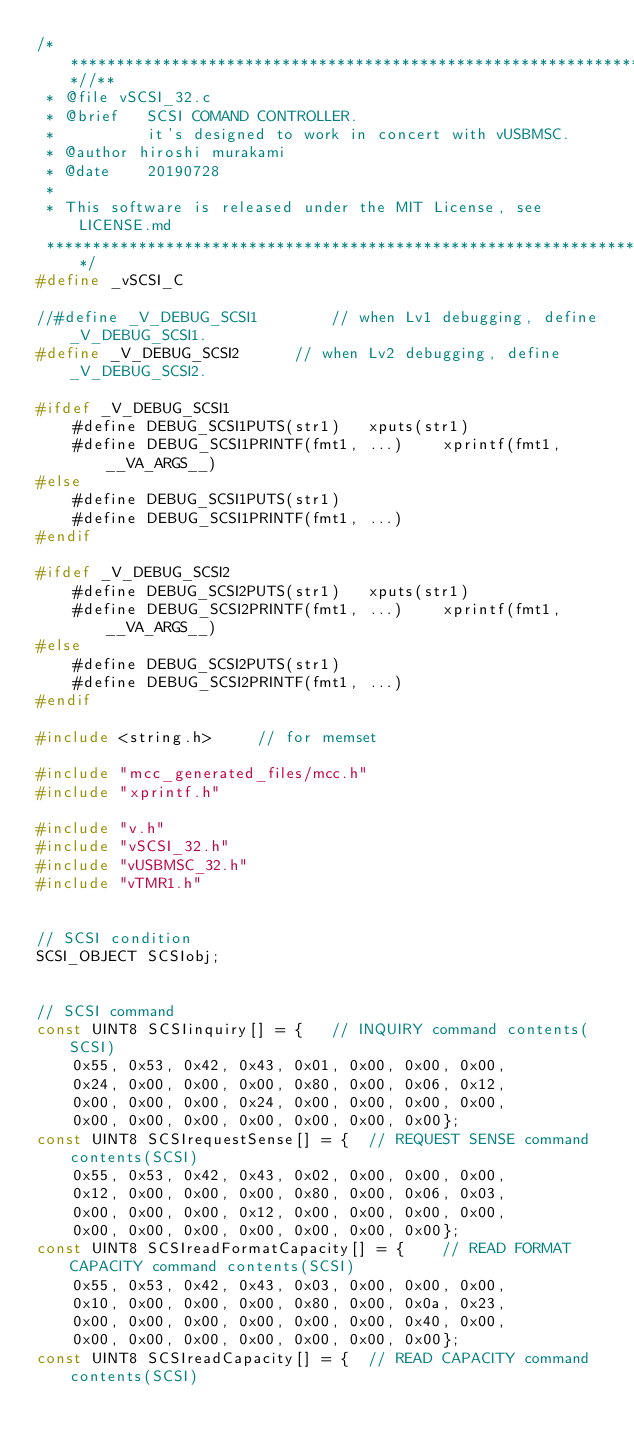Convert code to text. <code><loc_0><loc_0><loc_500><loc_500><_C_>/***************************************************************************//**
 * @file vSCSI_32.c
 * @brief	SCSI COMAND CONTROLLER.
 *			it's designed to work in concert with vUSBMSC.
 * @author hiroshi murakami
 * @date	20190728
 *
 * This software is released under the MIT License, see LICENSE.md
 ******************************************************************************/
#define _vSCSI_C

//#define _V_DEBUG_SCSI1		// when Lv1 debugging, define _V_DEBUG_SCSI1. 
#define _V_DEBUG_SCSI2		// when Lv2 debugging, define _V_DEBUG_SCSI2. 

#ifdef _V_DEBUG_SCSI1
	#define	DEBUG_SCSI1PUTS(str1)	xputs(str1)
	#define	DEBUG_SCSI1PRINTF(fmt1, ...)	xprintf(fmt1, __VA_ARGS__)
#else
	#define	DEBUG_SCSI1PUTS(str1)
	#define	DEBUG_SCSI1PRINTF(fmt1, ...)
#endif

#ifdef _V_DEBUG_SCSI2
	#define	DEBUG_SCSI2PUTS(str1)	xputs(str1)
	#define	DEBUG_SCSI2PRINTF(fmt1, ...)	xprintf(fmt1, __VA_ARGS__)
#else
	#define	DEBUG_SCSI2PUTS(str1)
	#define	DEBUG_SCSI2PRINTF(fmt1, ...)
#endif

#include <string.h>		// for memset

#include "mcc_generated_files/mcc.h"
#include "xprintf.h"

#include "v.h"
#include "vSCSI_32.h"
#include "vUSBMSC_32.h"
#include "vTMR1.h"


// SCSI condition
SCSI_OBJECT SCSIobj;


// SCSI command
const UINT8 SCSIinquiry[] = {	// INQUIRY command contents(SCSI)
	0x55, 0x53, 0x42, 0x43, 0x01, 0x00, 0x00, 0x00,
	0x24, 0x00, 0x00, 0x00, 0x80, 0x00, 0x06, 0x12,
	0x00, 0x00, 0x00, 0x24, 0x00, 0x00, 0x00, 0x00,
	0x00, 0x00, 0x00, 0x00, 0x00, 0x00, 0x00};
const UINT8 SCSIrequestSense[] = {	// REQUEST SENSE command contents(SCSI)
	0x55, 0x53, 0x42, 0x43, 0x02, 0x00, 0x00, 0x00,
	0x12, 0x00, 0x00, 0x00, 0x80, 0x00, 0x06, 0x03,
	0x00, 0x00, 0x00, 0x12, 0x00, 0x00, 0x00, 0x00,
	0x00, 0x00, 0x00, 0x00, 0x00, 0x00, 0x00};
const UINT8 SCSIreadFormatCapacity[] = {	// READ FORMAT CAPACITY command contents(SCSI)
	0x55, 0x53, 0x42, 0x43, 0x03, 0x00, 0x00, 0x00,
	0x10, 0x00, 0x00, 0x00, 0x80, 0x00, 0x0a, 0x23,
	0x00, 0x00, 0x00, 0x00, 0x00, 0x00, 0x40, 0x00,
	0x00, 0x00, 0x00, 0x00, 0x00, 0x00, 0x00};
const UINT8 SCSIreadCapacity[] = {	// READ CAPACITY command contents(SCSI)</code> 